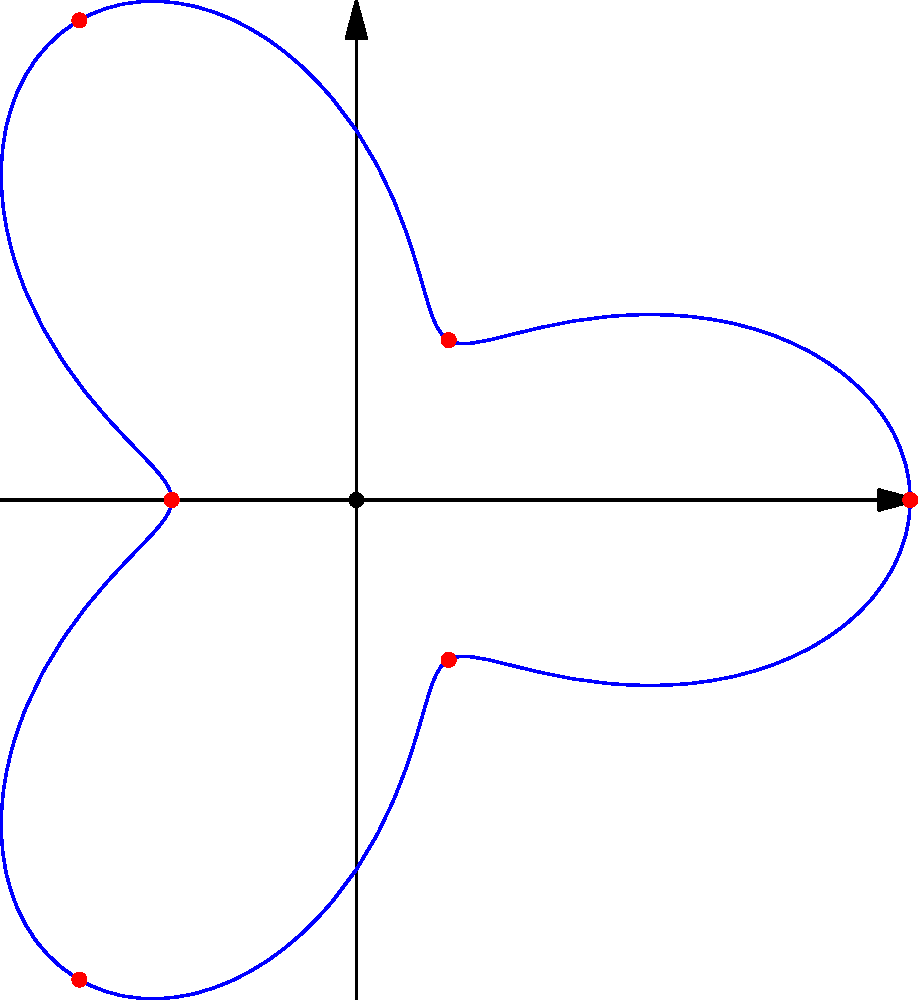During a karate demonstration, you arrange your students in a circular formation around you. The radial distance of each student from the center (where you stand) varies according to the function $r(\theta) = 2 + \cos(3\theta)$, where $r$ is in meters and $\theta$ is in radians. How many times does a student's position reach the maximum distance from the center as they complete one full revolution around you? To solve this problem, we need to analyze the given polar function:

1) The function is $r(\theta) = 2 + \cos(3\theta)$

2) The maximum distance occurs when $\cos(3\theta)$ reaches its maximum value of 1.

3) $\cos(3\theta) = 1$ when $3\theta = 0, 2\pi, 4\pi, ...$

4) Solving for $\theta$:
   $\theta = 0, \frac{2\pi}{3}, \frac{4\pi}{3}, 2\pi$

5) Within one full revolution $(0 \leq \theta < 2\pi)$, we have three solutions:
   $\theta = 0, \frac{2\pi}{3}, \frac{4\pi}{3}$

6) Therefore, the maximum distance is reached three times in one full revolution.

This pattern is visible in the polar graph, where we can see three "petals" or lobes, each corresponding to a maximum distance from the center.
Answer: 3 times 